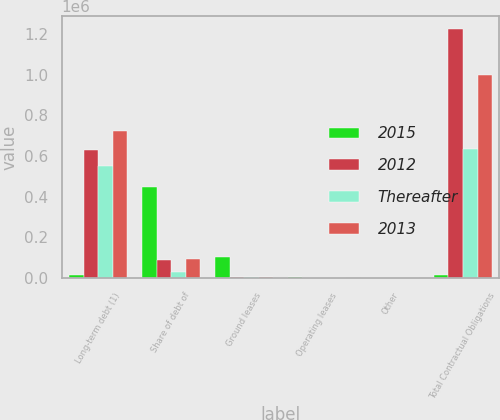Convert chart to OTSL. <chart><loc_0><loc_0><loc_500><loc_500><stacked_bar_chart><ecel><fcel>Long-term debt (1)<fcel>Share of debt of<fcel>Ground leases<fcel>Operating leases<fcel>Other<fcel>Total Contractual Obligations<nl><fcel>2015<fcel>14936.5<fcel>447573<fcel>103563<fcel>2704<fcel>1967<fcel>14936.5<nl><fcel>2012<fcel>629781<fcel>87602<fcel>2199<fcel>840<fcel>1015<fcel>1.2258e+06<nl><fcel>Thereafter<fcel>548966<fcel>27169<fcel>2198<fcel>419<fcel>398<fcel>633481<nl><fcel>2013<fcel>725060<fcel>93663<fcel>2169<fcel>395<fcel>229<fcel>998091<nl></chart> 